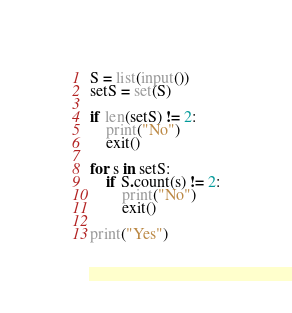<code> <loc_0><loc_0><loc_500><loc_500><_Python_>S = list(input())
setS = set(S)

if len(setS) != 2:
    print("No")
    exit()
    
for s in setS:
    if S.count(s) != 2:
        print("No")
        exit()

print("Yes")
</code> 